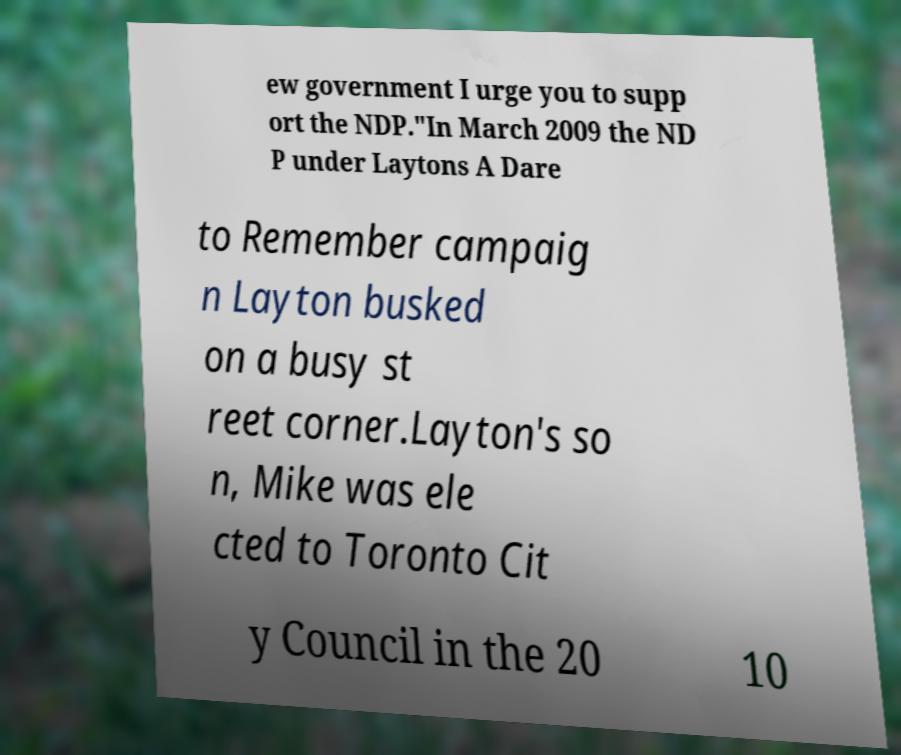I need the written content from this picture converted into text. Can you do that? ew government I urge you to supp ort the NDP."In March 2009 the ND P under Laytons A Dare to Remember campaig n Layton busked on a busy st reet corner.Layton's so n, Mike was ele cted to Toronto Cit y Council in the 20 10 